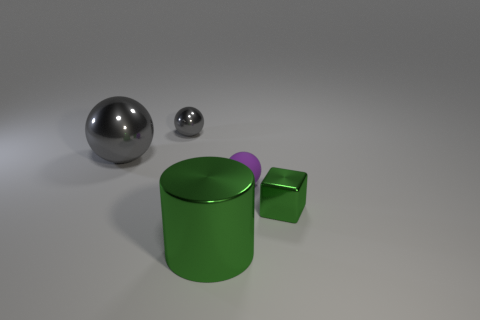There is a big object that is the same shape as the tiny gray thing; what is its material?
Keep it short and to the point. Metal. Do the small purple rubber object and the large green object have the same shape?
Offer a terse response. No. What is the shape of the gray object that is made of the same material as the small gray ball?
Your response must be concise. Sphere. Does the green metal object that is to the left of the tiny green thing have the same size as the green metal object that is on the right side of the green cylinder?
Provide a short and direct response. No. Is the number of purple matte balls in front of the large gray ball greater than the number of spheres that are in front of the small green metal object?
Give a very brief answer. Yes. How many other things are the same color as the tiny metallic block?
Make the answer very short. 1. Is the color of the tiny block the same as the big thing that is in front of the small cube?
Keep it short and to the point. Yes. There is a shiny thing in front of the small block; what number of tiny metallic things are left of it?
Make the answer very short. 1. Is there anything else that has the same material as the tiny purple thing?
Keep it short and to the point. No. The small thing that is behind the big object that is to the left of the tiny object behind the big gray metallic ball is made of what material?
Provide a succinct answer. Metal. 